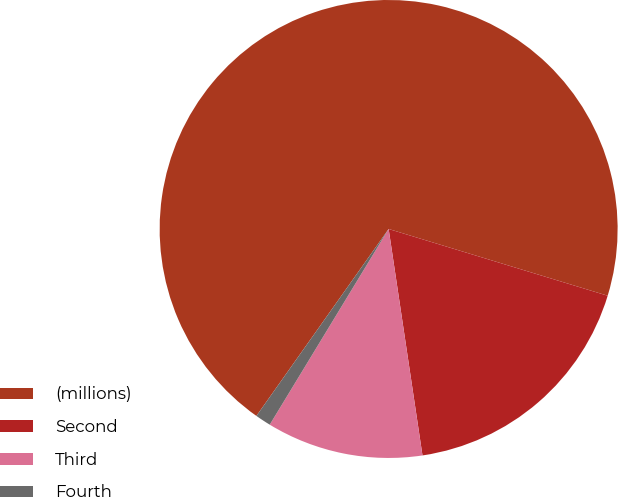Convert chart to OTSL. <chart><loc_0><loc_0><loc_500><loc_500><pie_chart><fcel>(millions)<fcel>Second<fcel>Third<fcel>Fourth<nl><fcel>69.91%<fcel>17.93%<fcel>11.05%<fcel>1.11%<nl></chart> 